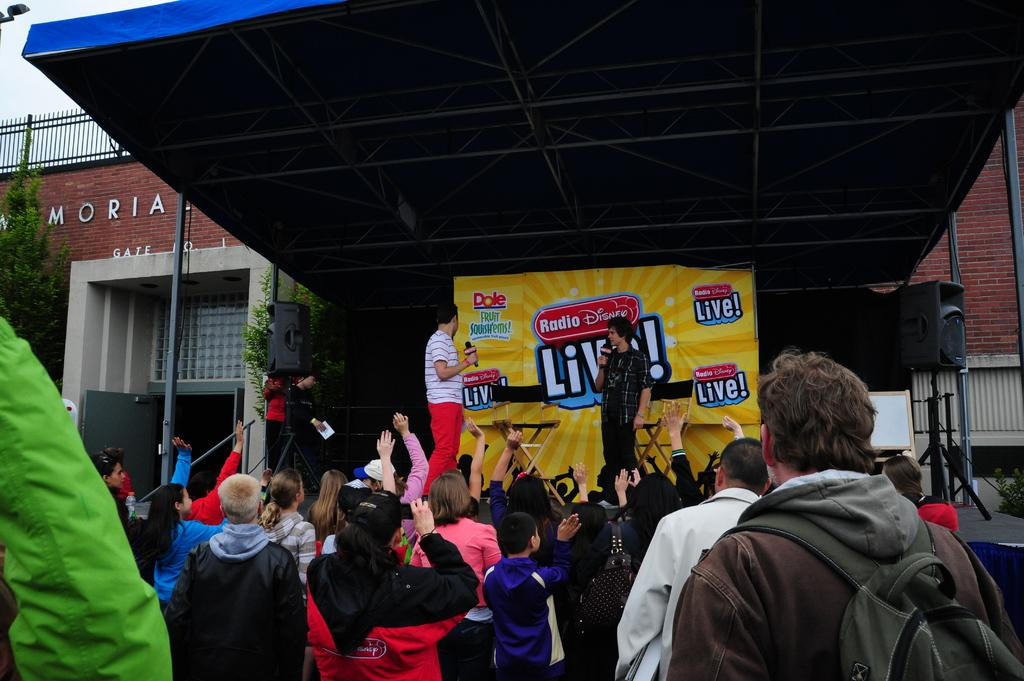How many people are visible in the image? There are people in the image, specifically three persons standing on a stage. What is the setting of the image? The setting of the image is a stage, with a building in the background. What can be seen on the building in the background? There is text written on the building in the image. How many chickens are visible on the stage in the image? There are no chickens visible on the stage in the image. What type of screw is being used to hold the building together in the image? There is no visible screw in the image, and the building's construction is not mentioned in the provided facts. 